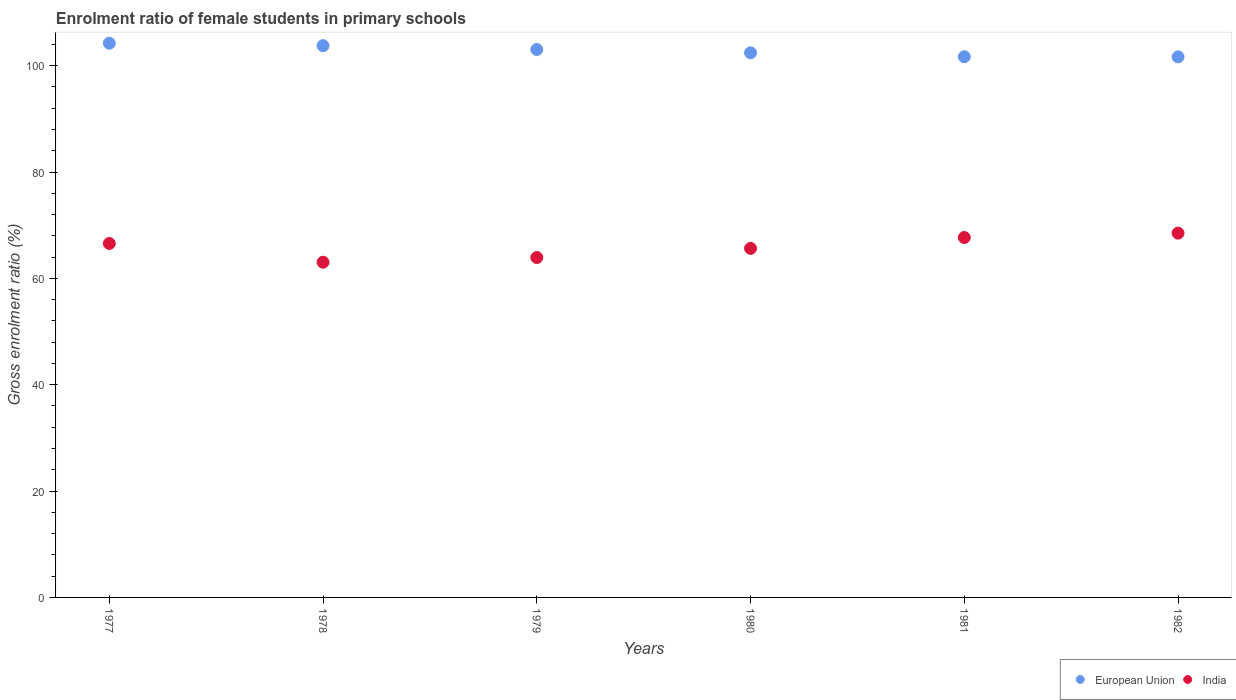Is the number of dotlines equal to the number of legend labels?
Give a very brief answer. Yes. What is the enrolment ratio of female students in primary schools in India in 1977?
Your answer should be very brief. 66.56. Across all years, what is the maximum enrolment ratio of female students in primary schools in India?
Offer a very short reply. 68.51. Across all years, what is the minimum enrolment ratio of female students in primary schools in India?
Your response must be concise. 63.04. In which year was the enrolment ratio of female students in primary schools in European Union minimum?
Your response must be concise. 1982. What is the total enrolment ratio of female students in primary schools in European Union in the graph?
Provide a succinct answer. 616.79. What is the difference between the enrolment ratio of female students in primary schools in India in 1978 and that in 1981?
Your answer should be compact. -4.65. What is the difference between the enrolment ratio of female students in primary schools in European Union in 1979 and the enrolment ratio of female students in primary schools in India in 1980?
Offer a very short reply. 37.4. What is the average enrolment ratio of female students in primary schools in India per year?
Offer a terse response. 65.89. In the year 1978, what is the difference between the enrolment ratio of female students in primary schools in India and enrolment ratio of female students in primary schools in European Union?
Offer a very short reply. -40.72. What is the ratio of the enrolment ratio of female students in primary schools in European Union in 1977 to that in 1981?
Ensure brevity in your answer.  1.03. What is the difference between the highest and the second highest enrolment ratio of female students in primary schools in India?
Give a very brief answer. 0.82. What is the difference between the highest and the lowest enrolment ratio of female students in primary schools in European Union?
Offer a terse response. 2.57. In how many years, is the enrolment ratio of female students in primary schools in European Union greater than the average enrolment ratio of female students in primary schools in European Union taken over all years?
Offer a very short reply. 3. Does the enrolment ratio of female students in primary schools in India monotonically increase over the years?
Make the answer very short. No. How many dotlines are there?
Give a very brief answer. 2. What is the difference between two consecutive major ticks on the Y-axis?
Offer a terse response. 20. Are the values on the major ticks of Y-axis written in scientific E-notation?
Offer a very short reply. No. Does the graph contain any zero values?
Provide a succinct answer. No. What is the title of the graph?
Offer a terse response. Enrolment ratio of female students in primary schools. What is the Gross enrolment ratio (%) in European Union in 1977?
Your response must be concise. 104.23. What is the Gross enrolment ratio (%) in India in 1977?
Make the answer very short. 66.56. What is the Gross enrolment ratio (%) in European Union in 1978?
Offer a very short reply. 103.76. What is the Gross enrolment ratio (%) of India in 1978?
Make the answer very short. 63.04. What is the Gross enrolment ratio (%) of European Union in 1979?
Provide a short and direct response. 103.04. What is the Gross enrolment ratio (%) in India in 1979?
Offer a very short reply. 63.93. What is the Gross enrolment ratio (%) of European Union in 1980?
Keep it short and to the point. 102.42. What is the Gross enrolment ratio (%) of India in 1980?
Provide a succinct answer. 65.64. What is the Gross enrolment ratio (%) in European Union in 1981?
Provide a succinct answer. 101.68. What is the Gross enrolment ratio (%) of India in 1981?
Ensure brevity in your answer.  67.69. What is the Gross enrolment ratio (%) of European Union in 1982?
Offer a very short reply. 101.65. What is the Gross enrolment ratio (%) in India in 1982?
Your answer should be very brief. 68.51. Across all years, what is the maximum Gross enrolment ratio (%) of European Union?
Your response must be concise. 104.23. Across all years, what is the maximum Gross enrolment ratio (%) of India?
Make the answer very short. 68.51. Across all years, what is the minimum Gross enrolment ratio (%) of European Union?
Make the answer very short. 101.65. Across all years, what is the minimum Gross enrolment ratio (%) of India?
Ensure brevity in your answer.  63.04. What is the total Gross enrolment ratio (%) of European Union in the graph?
Your response must be concise. 616.79. What is the total Gross enrolment ratio (%) of India in the graph?
Ensure brevity in your answer.  395.36. What is the difference between the Gross enrolment ratio (%) in European Union in 1977 and that in 1978?
Offer a very short reply. 0.47. What is the difference between the Gross enrolment ratio (%) in India in 1977 and that in 1978?
Make the answer very short. 3.52. What is the difference between the Gross enrolment ratio (%) in European Union in 1977 and that in 1979?
Provide a succinct answer. 1.18. What is the difference between the Gross enrolment ratio (%) of India in 1977 and that in 1979?
Your answer should be compact. 2.64. What is the difference between the Gross enrolment ratio (%) of European Union in 1977 and that in 1980?
Ensure brevity in your answer.  1.81. What is the difference between the Gross enrolment ratio (%) of India in 1977 and that in 1980?
Provide a succinct answer. 0.92. What is the difference between the Gross enrolment ratio (%) in European Union in 1977 and that in 1981?
Your answer should be very brief. 2.55. What is the difference between the Gross enrolment ratio (%) in India in 1977 and that in 1981?
Ensure brevity in your answer.  -1.12. What is the difference between the Gross enrolment ratio (%) in European Union in 1977 and that in 1982?
Your answer should be compact. 2.57. What is the difference between the Gross enrolment ratio (%) of India in 1977 and that in 1982?
Your answer should be very brief. -1.95. What is the difference between the Gross enrolment ratio (%) in European Union in 1978 and that in 1979?
Make the answer very short. 0.71. What is the difference between the Gross enrolment ratio (%) of India in 1978 and that in 1979?
Ensure brevity in your answer.  -0.89. What is the difference between the Gross enrolment ratio (%) in European Union in 1978 and that in 1980?
Provide a short and direct response. 1.34. What is the difference between the Gross enrolment ratio (%) in India in 1978 and that in 1980?
Provide a short and direct response. -2.6. What is the difference between the Gross enrolment ratio (%) in European Union in 1978 and that in 1981?
Offer a very short reply. 2.08. What is the difference between the Gross enrolment ratio (%) of India in 1978 and that in 1981?
Your answer should be compact. -4.65. What is the difference between the Gross enrolment ratio (%) in European Union in 1978 and that in 1982?
Offer a terse response. 2.1. What is the difference between the Gross enrolment ratio (%) in India in 1978 and that in 1982?
Make the answer very short. -5.47. What is the difference between the Gross enrolment ratio (%) in European Union in 1979 and that in 1980?
Ensure brevity in your answer.  0.62. What is the difference between the Gross enrolment ratio (%) of India in 1979 and that in 1980?
Your answer should be compact. -1.72. What is the difference between the Gross enrolment ratio (%) in European Union in 1979 and that in 1981?
Give a very brief answer. 1.36. What is the difference between the Gross enrolment ratio (%) in India in 1979 and that in 1981?
Offer a terse response. -3.76. What is the difference between the Gross enrolment ratio (%) in European Union in 1979 and that in 1982?
Offer a very short reply. 1.39. What is the difference between the Gross enrolment ratio (%) in India in 1979 and that in 1982?
Your answer should be compact. -4.58. What is the difference between the Gross enrolment ratio (%) in European Union in 1980 and that in 1981?
Ensure brevity in your answer.  0.74. What is the difference between the Gross enrolment ratio (%) in India in 1980 and that in 1981?
Your answer should be very brief. -2.05. What is the difference between the Gross enrolment ratio (%) of European Union in 1980 and that in 1982?
Ensure brevity in your answer.  0.77. What is the difference between the Gross enrolment ratio (%) of India in 1980 and that in 1982?
Your answer should be compact. -2.87. What is the difference between the Gross enrolment ratio (%) of European Union in 1981 and that in 1982?
Provide a succinct answer. 0.03. What is the difference between the Gross enrolment ratio (%) of India in 1981 and that in 1982?
Make the answer very short. -0.82. What is the difference between the Gross enrolment ratio (%) of European Union in 1977 and the Gross enrolment ratio (%) of India in 1978?
Provide a short and direct response. 41.19. What is the difference between the Gross enrolment ratio (%) in European Union in 1977 and the Gross enrolment ratio (%) in India in 1979?
Offer a very short reply. 40.3. What is the difference between the Gross enrolment ratio (%) of European Union in 1977 and the Gross enrolment ratio (%) of India in 1980?
Offer a very short reply. 38.59. What is the difference between the Gross enrolment ratio (%) of European Union in 1977 and the Gross enrolment ratio (%) of India in 1981?
Your response must be concise. 36.54. What is the difference between the Gross enrolment ratio (%) of European Union in 1977 and the Gross enrolment ratio (%) of India in 1982?
Give a very brief answer. 35.72. What is the difference between the Gross enrolment ratio (%) in European Union in 1978 and the Gross enrolment ratio (%) in India in 1979?
Offer a terse response. 39.83. What is the difference between the Gross enrolment ratio (%) of European Union in 1978 and the Gross enrolment ratio (%) of India in 1980?
Keep it short and to the point. 38.12. What is the difference between the Gross enrolment ratio (%) in European Union in 1978 and the Gross enrolment ratio (%) in India in 1981?
Your answer should be compact. 36.07. What is the difference between the Gross enrolment ratio (%) in European Union in 1978 and the Gross enrolment ratio (%) in India in 1982?
Offer a terse response. 35.25. What is the difference between the Gross enrolment ratio (%) in European Union in 1979 and the Gross enrolment ratio (%) in India in 1980?
Offer a terse response. 37.4. What is the difference between the Gross enrolment ratio (%) in European Union in 1979 and the Gross enrolment ratio (%) in India in 1981?
Offer a terse response. 35.36. What is the difference between the Gross enrolment ratio (%) of European Union in 1979 and the Gross enrolment ratio (%) of India in 1982?
Provide a short and direct response. 34.54. What is the difference between the Gross enrolment ratio (%) of European Union in 1980 and the Gross enrolment ratio (%) of India in 1981?
Offer a very short reply. 34.74. What is the difference between the Gross enrolment ratio (%) of European Union in 1980 and the Gross enrolment ratio (%) of India in 1982?
Your answer should be compact. 33.91. What is the difference between the Gross enrolment ratio (%) in European Union in 1981 and the Gross enrolment ratio (%) in India in 1982?
Offer a terse response. 33.17. What is the average Gross enrolment ratio (%) of European Union per year?
Provide a short and direct response. 102.8. What is the average Gross enrolment ratio (%) of India per year?
Ensure brevity in your answer.  65.89. In the year 1977, what is the difference between the Gross enrolment ratio (%) in European Union and Gross enrolment ratio (%) in India?
Your answer should be compact. 37.67. In the year 1978, what is the difference between the Gross enrolment ratio (%) in European Union and Gross enrolment ratio (%) in India?
Offer a very short reply. 40.72. In the year 1979, what is the difference between the Gross enrolment ratio (%) of European Union and Gross enrolment ratio (%) of India?
Offer a very short reply. 39.12. In the year 1980, what is the difference between the Gross enrolment ratio (%) in European Union and Gross enrolment ratio (%) in India?
Provide a succinct answer. 36.78. In the year 1981, what is the difference between the Gross enrolment ratio (%) of European Union and Gross enrolment ratio (%) of India?
Your response must be concise. 33.99. In the year 1982, what is the difference between the Gross enrolment ratio (%) in European Union and Gross enrolment ratio (%) in India?
Keep it short and to the point. 33.15. What is the ratio of the Gross enrolment ratio (%) of India in 1977 to that in 1978?
Provide a succinct answer. 1.06. What is the ratio of the Gross enrolment ratio (%) of European Union in 1977 to that in 1979?
Ensure brevity in your answer.  1.01. What is the ratio of the Gross enrolment ratio (%) in India in 1977 to that in 1979?
Your answer should be compact. 1.04. What is the ratio of the Gross enrolment ratio (%) of European Union in 1977 to that in 1980?
Make the answer very short. 1.02. What is the ratio of the Gross enrolment ratio (%) of India in 1977 to that in 1980?
Provide a short and direct response. 1.01. What is the ratio of the Gross enrolment ratio (%) in India in 1977 to that in 1981?
Ensure brevity in your answer.  0.98. What is the ratio of the Gross enrolment ratio (%) in European Union in 1977 to that in 1982?
Ensure brevity in your answer.  1.03. What is the ratio of the Gross enrolment ratio (%) of India in 1977 to that in 1982?
Your answer should be very brief. 0.97. What is the ratio of the Gross enrolment ratio (%) of India in 1978 to that in 1979?
Offer a terse response. 0.99. What is the ratio of the Gross enrolment ratio (%) in European Union in 1978 to that in 1980?
Give a very brief answer. 1.01. What is the ratio of the Gross enrolment ratio (%) in India in 1978 to that in 1980?
Provide a succinct answer. 0.96. What is the ratio of the Gross enrolment ratio (%) in European Union in 1978 to that in 1981?
Offer a very short reply. 1.02. What is the ratio of the Gross enrolment ratio (%) in India in 1978 to that in 1981?
Your response must be concise. 0.93. What is the ratio of the Gross enrolment ratio (%) of European Union in 1978 to that in 1982?
Your answer should be compact. 1.02. What is the ratio of the Gross enrolment ratio (%) in India in 1978 to that in 1982?
Give a very brief answer. 0.92. What is the ratio of the Gross enrolment ratio (%) of India in 1979 to that in 1980?
Give a very brief answer. 0.97. What is the ratio of the Gross enrolment ratio (%) of European Union in 1979 to that in 1981?
Keep it short and to the point. 1.01. What is the ratio of the Gross enrolment ratio (%) of India in 1979 to that in 1981?
Your response must be concise. 0.94. What is the ratio of the Gross enrolment ratio (%) of European Union in 1979 to that in 1982?
Your response must be concise. 1.01. What is the ratio of the Gross enrolment ratio (%) of India in 1979 to that in 1982?
Make the answer very short. 0.93. What is the ratio of the Gross enrolment ratio (%) in European Union in 1980 to that in 1981?
Offer a very short reply. 1.01. What is the ratio of the Gross enrolment ratio (%) of India in 1980 to that in 1981?
Provide a succinct answer. 0.97. What is the ratio of the Gross enrolment ratio (%) of European Union in 1980 to that in 1982?
Keep it short and to the point. 1.01. What is the ratio of the Gross enrolment ratio (%) in India in 1980 to that in 1982?
Your answer should be compact. 0.96. What is the ratio of the Gross enrolment ratio (%) in European Union in 1981 to that in 1982?
Your answer should be very brief. 1. What is the difference between the highest and the second highest Gross enrolment ratio (%) in European Union?
Make the answer very short. 0.47. What is the difference between the highest and the second highest Gross enrolment ratio (%) in India?
Your answer should be very brief. 0.82. What is the difference between the highest and the lowest Gross enrolment ratio (%) in European Union?
Your answer should be very brief. 2.57. What is the difference between the highest and the lowest Gross enrolment ratio (%) of India?
Your answer should be compact. 5.47. 